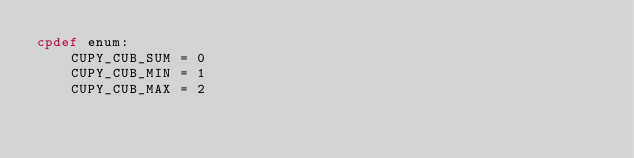<code> <loc_0><loc_0><loc_500><loc_500><_Cython_>cpdef enum:
    CUPY_CUB_SUM = 0
    CUPY_CUB_MIN = 1
    CUPY_CUB_MAX = 2
</code> 